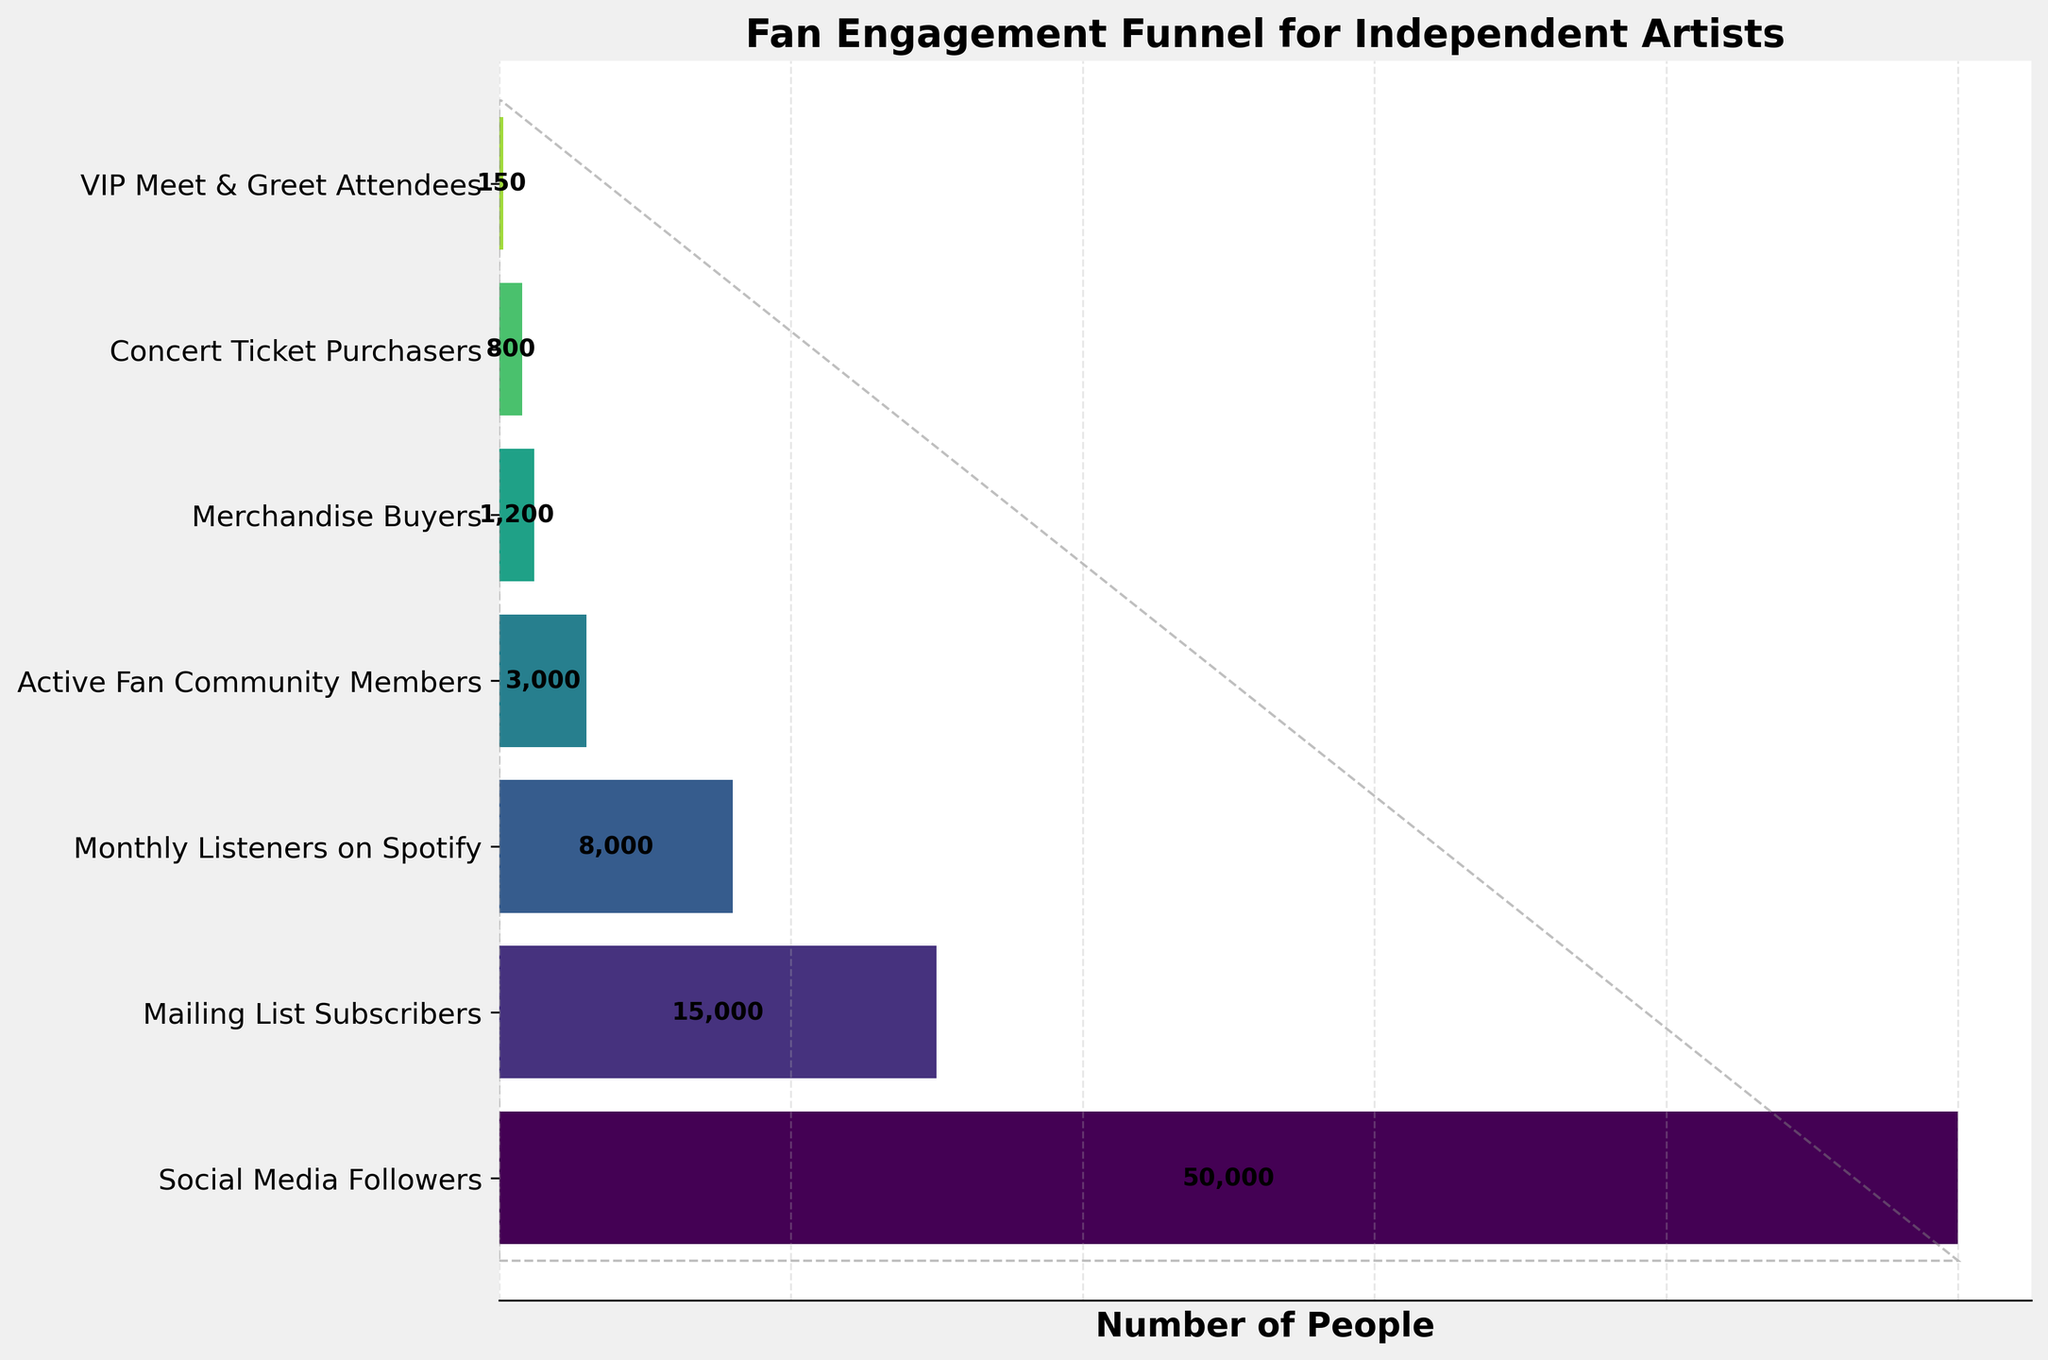What is the most populous stage in the fan engagement funnel? The most populous stage in the fan engagement funnel is simply the stage with the highest number of people. According to the figure, 'Social Media Followers' is the stage that has the highest value of 50,000.
Answer: Social Media Followers Which stage has the lowest number of people? The stage with the lowest number of people is found by identifying the smallest number in the funnel. According to the funnel, 'VIP Meet & Greet Attendees' has the lowest count at 150.
Answer: VIP Meet & Greet Attendees What's the total number of people from 'Mailing List Subscribers' to 'Concert Ticket Purchasers'? To find the total number of people from 'Mailing List Subscribers' to 'Concert Ticket Purchasers', sum the values from those stages. So, 15,000 + 8,000 + 3,000 + 1,200 + 800 = 28,000.
Answer: 28,000 How many more social media followers are there compared to concert ticket purchasers? To find out how many more social media followers there are compared to concert ticket purchasers, subtract the number of concert ticket purchasers from the number of social media followers. So, 50,000 - 800 = 49,200.
Answer: 49,200 On average, how many people remain in each stage between 'Monthly Listeners on Spotify' and 'VIP Meet & Greet Attendees'? To find the average number of people from 'Monthly Listeners on Spotify' to 'VIP Meet & Greet Attendees', sum the values and then divide by the number of stages. So, (8,000 + 3,000 + 1,200 + 800 + 150) / 5 = 13,150 / 5 = 2,630.
Answer: 2,630 Which stage has around half the number of people compared to 'Mailing List Subscribers'? To find out which stage has around half the number of 'Mailing List Subscribers', identify the closest value to 15,000 / 2 = 7,500. The 'Monthly Listeners on Spotify' stage has 8,000, which is approximately half.
Answer: Monthly Listeners on Spotify What percentage of social media followers become VIP meet & greet attendees? To find the percentage, divide the number of VIP meet & greet attendees by the number of social media followers and multiply by 100. (150 / 50,000) * 100 = 0.3%.
Answer: 0.3% Analyze the decline in numbers from 'Active Fan Community Members' to 'Concert Ticket Purchasers'. What percentage drop is observed? To find the percentage drop, calculate the difference between the two stages, divide by the initial value and multiply by 100. ((3,000 - 800) / 3,000) * 100 = 73.33%.
Answer: 73.33% How many stages show a value below 5,000? Count the number of stages with fewer than 5,000 people. The stages with fewer than 5,000 people are 'Active Fan Community Members', 'Merchandise Buyers', 'Concert Ticket Purchasers', and 'VIP Meet & Greet Attendees'. There are 4 such stages.
Answer: 4 What is the median number of people in all stages? To find the median, list the values in ascending order (150, 800, 1,200, 3,000, 8,000, 15,000, 50,000) and find the middle value. The middle value is the 4th one, which is 3,000.
Answer: 3,000 